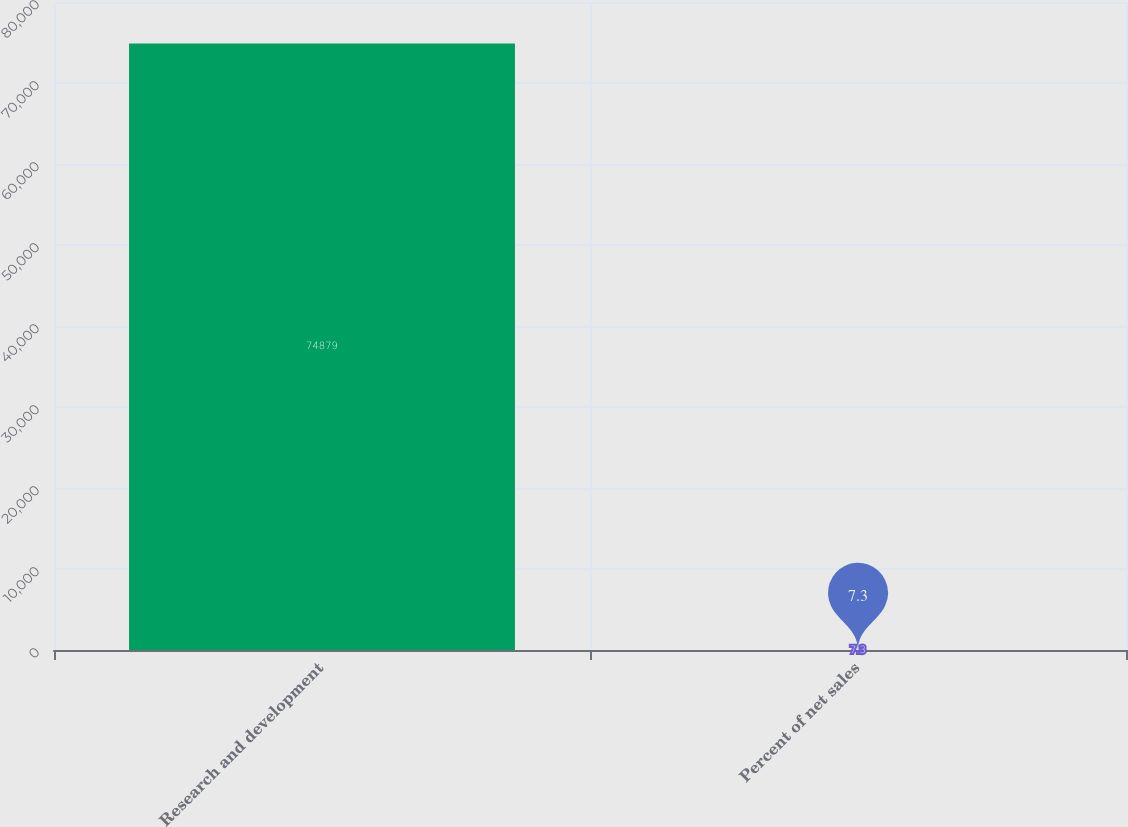Convert chart. <chart><loc_0><loc_0><loc_500><loc_500><bar_chart><fcel>Research and development<fcel>Percent of net sales<nl><fcel>74879<fcel>7.3<nl></chart> 